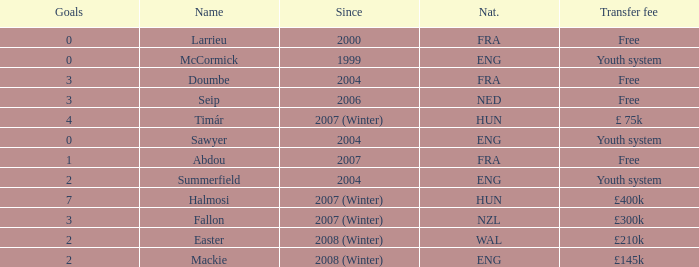Could you help me parse every detail presented in this table? {'header': ['Goals', 'Name', 'Since', 'Nat.', 'Transfer fee'], 'rows': [['0', 'Larrieu', '2000', 'FRA', 'Free'], ['0', 'McCormick', '1999', 'ENG', 'Youth system'], ['3', 'Doumbe', '2004', 'FRA', 'Free'], ['3', 'Seip', '2006', 'NED', 'Free'], ['4', 'Timár', '2007 (Winter)', 'HUN', '£ 75k'], ['0', 'Sawyer', '2004', 'ENG', 'Youth system'], ['1', 'Abdou', '2007', 'FRA', 'Free'], ['2', 'Summerfield', '2004', 'ENG', 'Youth system'], ['7', 'Halmosi', '2007 (Winter)', 'HUN', '£400k'], ['3', 'Fallon', '2007 (Winter)', 'NZL', '£300k'], ['2', 'Easter', '2008 (Winter)', 'WAL', '£210k'], ['2', 'Mackie', '2008 (Winter)', 'ENG', '£145k']]} What the since year of the player with a transfer fee of £ 75k? 2007 (Winter). 